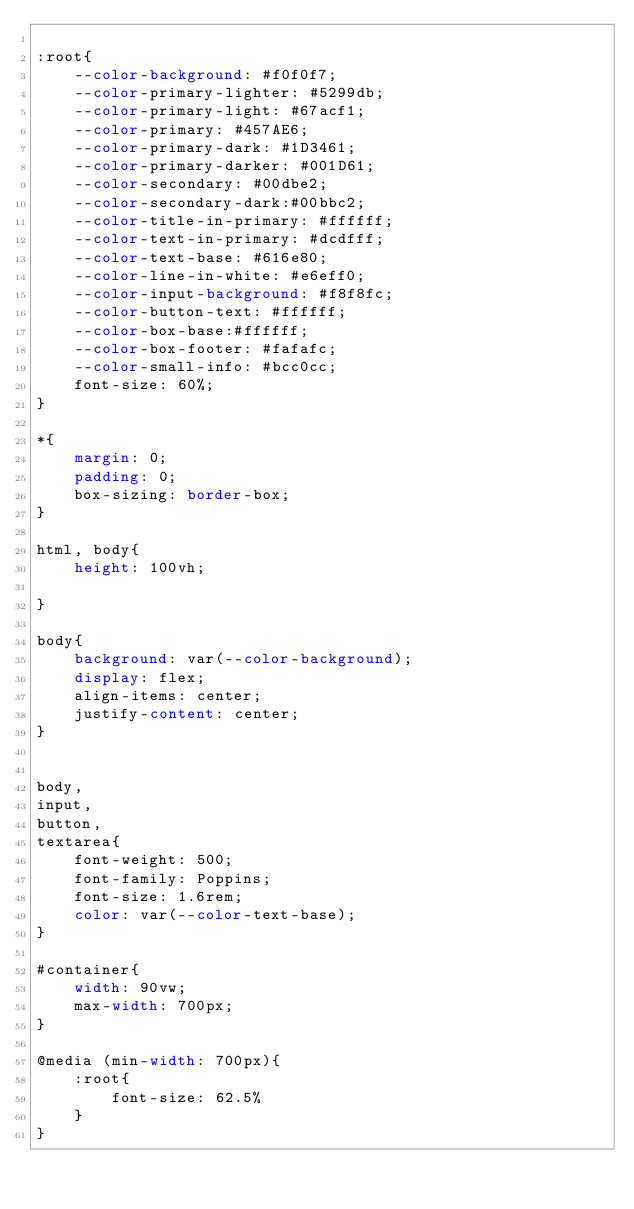<code> <loc_0><loc_0><loc_500><loc_500><_CSS_>
:root{
    --color-background: #f0f0f7;
    --color-primary-lighter: #5299db;
    --color-primary-light: #67acf1;
    --color-primary: #457AE6;
    --color-primary-dark: #1D3461;
    --color-primary-darker: #001D61;
    --color-secondary: #00dbe2;
    --color-secondary-dark:#00bbc2;
    --color-title-in-primary: #ffffff;
    --color-text-in-primary: #dcdfff;
    --color-text-base: #616e80;
    --color-line-in-white: #e6eff0;
    --color-input-background: #f8f8fc;
    --color-button-text: #ffffff;
    --color-box-base:#ffffff;
    --color-box-footer: #fafafc;
    --color-small-info: #bcc0cc;
    font-size: 60%;
}

*{
    margin: 0;
    padding: 0;
    box-sizing: border-box;
}

html, body{
    height: 100vh;

}

body{
    background: var(--color-background);
    display: flex;
    align-items: center;
    justify-content: center;
}


body, 
input, 
button, 
textarea{
    font-weight: 500;
    font-family: Poppins;
    font-size: 1.6rem;
    color: var(--color-text-base);
}

#container{
    width: 90vw;
    max-width: 700px;
}

@media (min-width: 700px){
    :root{
        font-size: 62.5%
    }
}</code> 